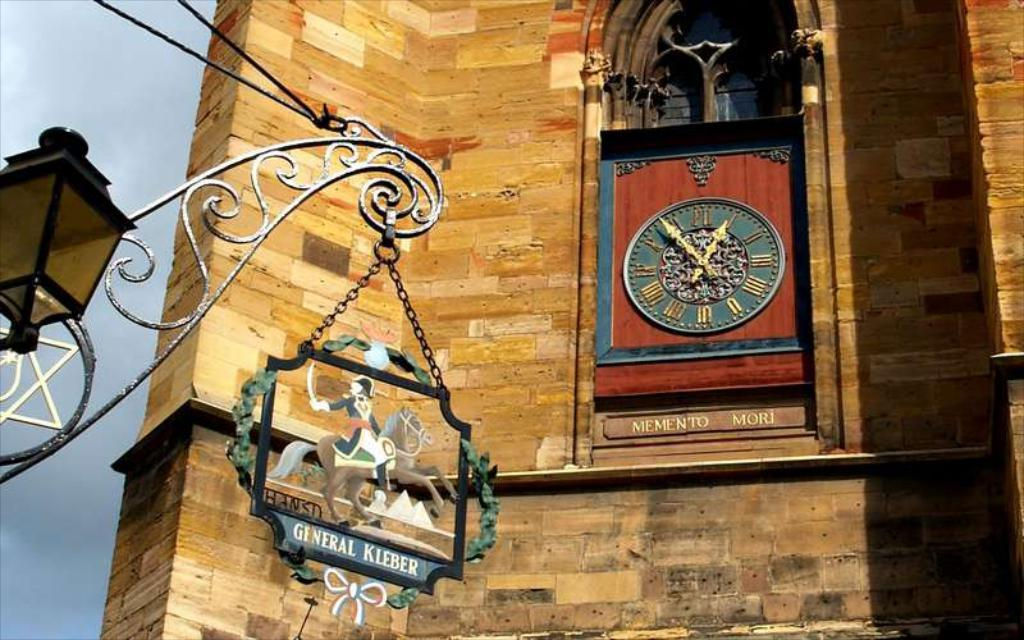<image>
Create a compact narrative representing the image presented. A piece of art depicting General Kleber hangs near a lamp adjacent to a large brick buulding with a beautiful wood and metal clock resting in it 